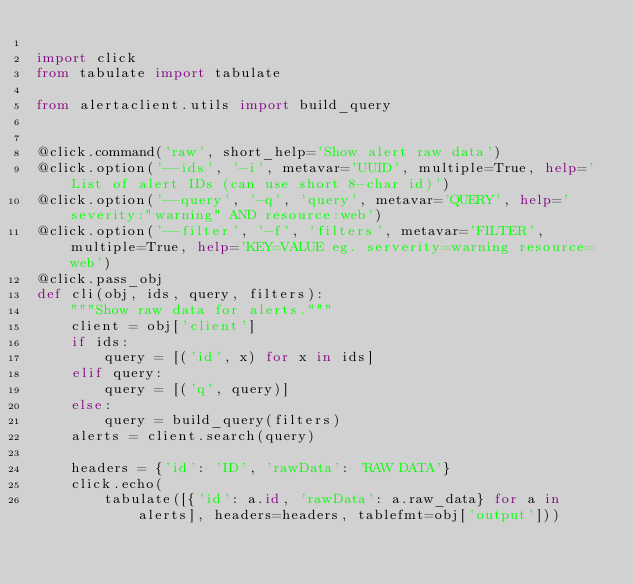<code> <loc_0><loc_0><loc_500><loc_500><_Python_>
import click
from tabulate import tabulate

from alertaclient.utils import build_query


@click.command('raw', short_help='Show alert raw data')
@click.option('--ids', '-i', metavar='UUID', multiple=True, help='List of alert IDs (can use short 8-char id)')
@click.option('--query', '-q', 'query', metavar='QUERY', help='severity:"warning" AND resource:web')
@click.option('--filter', '-f', 'filters', metavar='FILTER', multiple=True, help='KEY=VALUE eg. serverity=warning resource=web')
@click.pass_obj
def cli(obj, ids, query, filters):
    """Show raw data for alerts."""
    client = obj['client']
    if ids:
        query = [('id', x) for x in ids]
    elif query:
        query = [('q', query)]
    else:
        query = build_query(filters)
    alerts = client.search(query)

    headers = {'id': 'ID', 'rawData': 'RAW DATA'}
    click.echo(
        tabulate([{'id': a.id, 'rawData': a.raw_data} for a in alerts], headers=headers, tablefmt=obj['output']))
</code> 